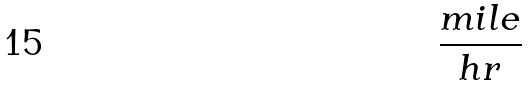<formula> <loc_0><loc_0><loc_500><loc_500>\frac { m i l e } { h r }</formula> 